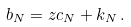Convert formula to latex. <formula><loc_0><loc_0><loc_500><loc_500>b _ { N } = z c _ { N } + k _ { N } \, .</formula> 